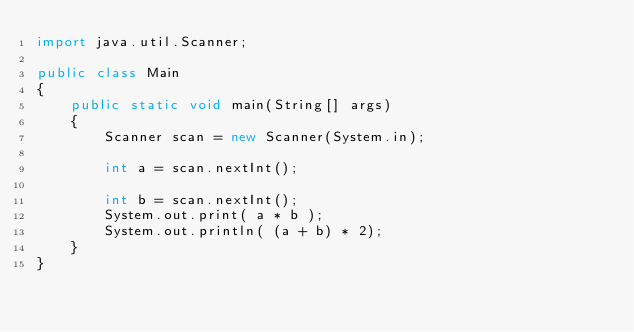<code> <loc_0><loc_0><loc_500><loc_500><_Java_>import java.util.Scanner;

public class Main
{  
    public static void main(String[] args) 
    {
        Scanner scan = new Scanner(System.in);

        int a = scan.nextInt();

        int b = scan.nextInt();
        System.out.print( a * b );
        System.out.println( (a + b) * 2);     
    } 
}
</code> 